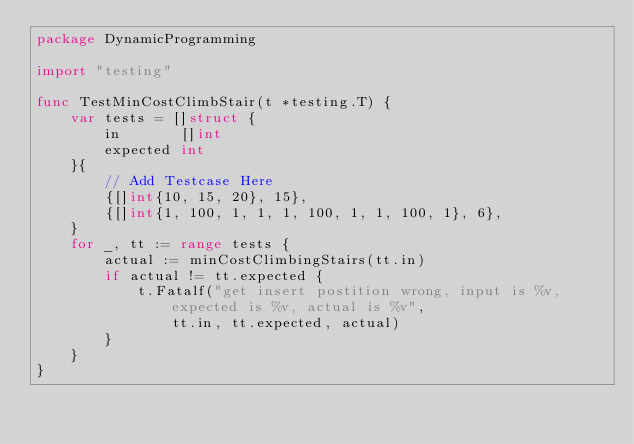<code> <loc_0><loc_0><loc_500><loc_500><_Go_>package DynamicProgramming

import "testing"

func TestMinCostClimbStair(t *testing.T) {
	var tests = []struct {
		in       []int
		expected int
	}{
		// Add Testcase Here
		{[]int{10, 15, 20}, 15},
		{[]int{1, 100, 1, 1, 1, 100, 1, 1, 100, 1}, 6},
	}
	for _, tt := range tests {
		actual := minCostClimbingStairs(tt.in)
		if actual != tt.expected {
			t.Fatalf("get insert postition wrong, input is %v, expected is %v, actual is %v",
				tt.in, tt.expected, actual)
		}
	}
}
</code> 